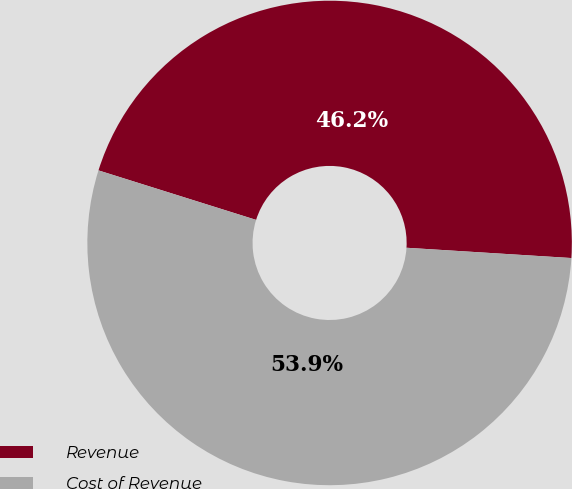<chart> <loc_0><loc_0><loc_500><loc_500><pie_chart><fcel>Revenue<fcel>Cost of Revenue<nl><fcel>46.15%<fcel>53.85%<nl></chart> 